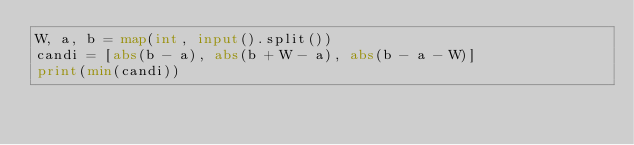<code> <loc_0><loc_0><loc_500><loc_500><_Python_>W, a, b = map(int, input().split())
candi = [abs(b - a), abs(b + W - a), abs(b - a - W)]
print(min(candi))
</code> 